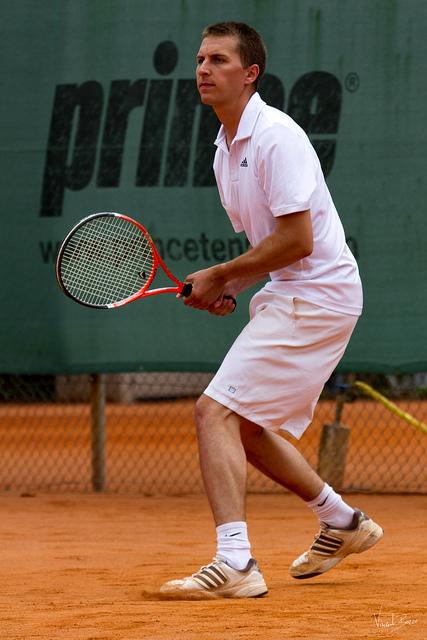How many stripes does each shoe have?
Concise answer only. 3. What lime green letter is on the right of the banner?
Concise answer only. E. What color are the man's shorts?
Quick response, please. White. What color is his shirt?
Concise answer only. White. Who is sponsoring the tournament?
Write a very short answer. Prince. What color is the tennis racket?
Concise answer only. Red. Is the man wearing nike shoes?
Keep it brief. No. Is the player a man?
Keep it brief. Yes. 